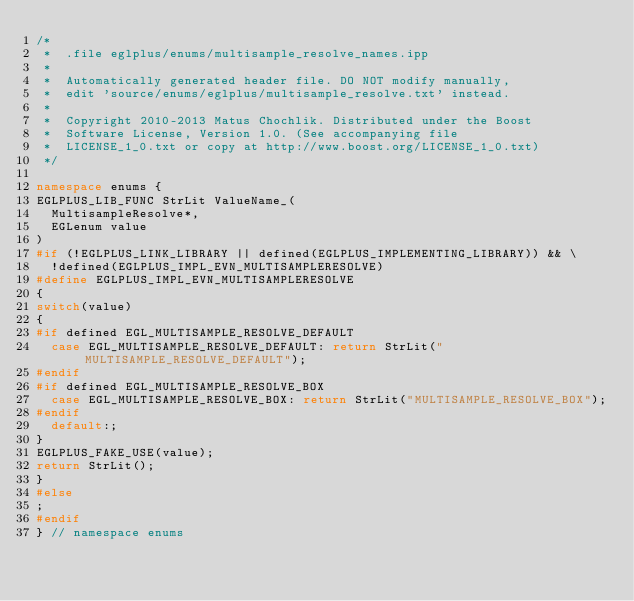<code> <loc_0><loc_0><loc_500><loc_500><_C++_>/*
 *  .file eglplus/enums/multisample_resolve_names.ipp
 *
 *  Automatically generated header file. DO NOT modify manually,
 *  edit 'source/enums/eglplus/multisample_resolve.txt' instead.
 *
 *  Copyright 2010-2013 Matus Chochlik. Distributed under the Boost
 *  Software License, Version 1.0. (See accompanying file
 *  LICENSE_1_0.txt or copy at http://www.boost.org/LICENSE_1_0.txt)
 */

namespace enums {
EGLPLUS_LIB_FUNC StrLit ValueName_(
	MultisampleResolve*,
	EGLenum value
)
#if (!EGLPLUS_LINK_LIBRARY || defined(EGLPLUS_IMPLEMENTING_LIBRARY)) && \
	!defined(EGLPLUS_IMPL_EVN_MULTISAMPLERESOLVE)
#define EGLPLUS_IMPL_EVN_MULTISAMPLERESOLVE
{
switch(value)
{
#if defined EGL_MULTISAMPLE_RESOLVE_DEFAULT
	case EGL_MULTISAMPLE_RESOLVE_DEFAULT: return StrLit("MULTISAMPLE_RESOLVE_DEFAULT");
#endif
#if defined EGL_MULTISAMPLE_RESOLVE_BOX
	case EGL_MULTISAMPLE_RESOLVE_BOX: return StrLit("MULTISAMPLE_RESOLVE_BOX");
#endif
	default:;
}
EGLPLUS_FAKE_USE(value);
return StrLit();
}
#else
;
#endif
} // namespace enums

</code> 